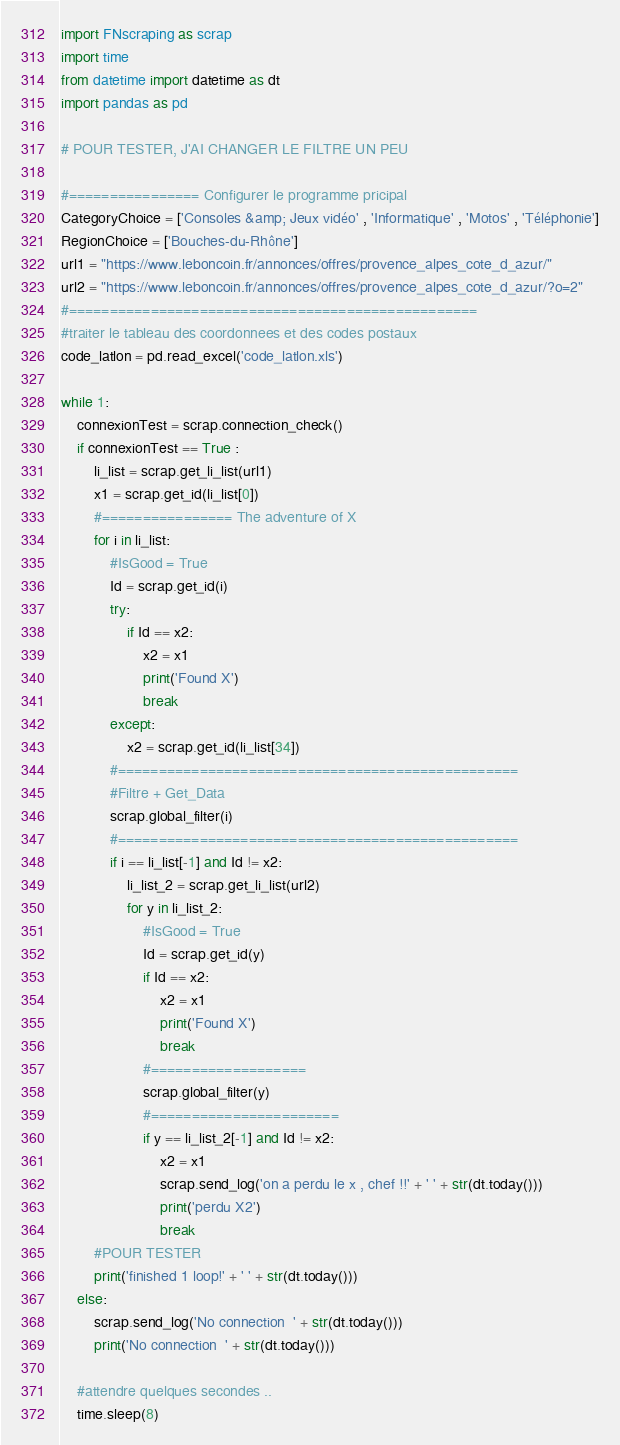Convert code to text. <code><loc_0><loc_0><loc_500><loc_500><_Python_>import FNscraping as scrap
import time
from datetime import datetime as dt
import pandas as pd

# POUR TESTER, J'AI CHANGER LE FILTRE UN PEU

#================ Configurer le programme pricipal
CategoryChoice = ['Consoles &amp; Jeux vidéo' , 'Informatique' , 'Motos' , 'Téléphonie']
RegionChoice = ['Bouches-du-Rhône']
url1 = "https://www.leboncoin.fr/annonces/offres/provence_alpes_cote_d_azur/"
url2 = "https://www.leboncoin.fr/annonces/offres/provence_alpes_cote_d_azur/?o=2"
#==================================================
#traiter le tableau des coordonnees et des codes postaux
code_latlon = pd.read_excel('code_latlon.xls')

while 1:
    connexionTest = scrap.connection_check()
    if connexionTest == True :
        li_list = scrap.get_li_list(url1)
        x1 = scrap.get_id(li_list[0])
        #================ The adventure of X
        for i in li_list:
            #IsGood = True    
            Id = scrap.get_id(i)
            try:
                if Id == x2:
                    x2 = x1
                    print('Found X')
                    break
            except:
                x2 = scrap.get_id(li_list[34])
            #=================================================
            #Filtre + Get_Data
            scrap.global_filter(i)
            #=================================================
            if i == li_list[-1] and Id != x2:
                li_list_2 = scrap.get_li_list(url2)
                for y in li_list_2:
                    #IsGood = True
                    Id = scrap.get_id(y)
                    if Id == x2:
                        x2 = x1
                        print('Found X')
                        break
                    #===================
                    scrap.global_filter(y)
                    #=======================
                    if y == li_list_2[-1] and Id != x2:
                        x2 = x1
                        scrap.send_log('on a perdu le x , chef !!' + ' ' + str(dt.today()))
                        print('perdu X2')
                        break
        #POUR TESTER
        print('finished 1 loop!' + ' ' + str(dt.today()))
    else:
        scrap.send_log('No connection  ' + str(dt.today()))
        print('No connection  ' + str(dt.today()))

    #attendre quelques secondes ..
    time.sleep(8)

</code> 